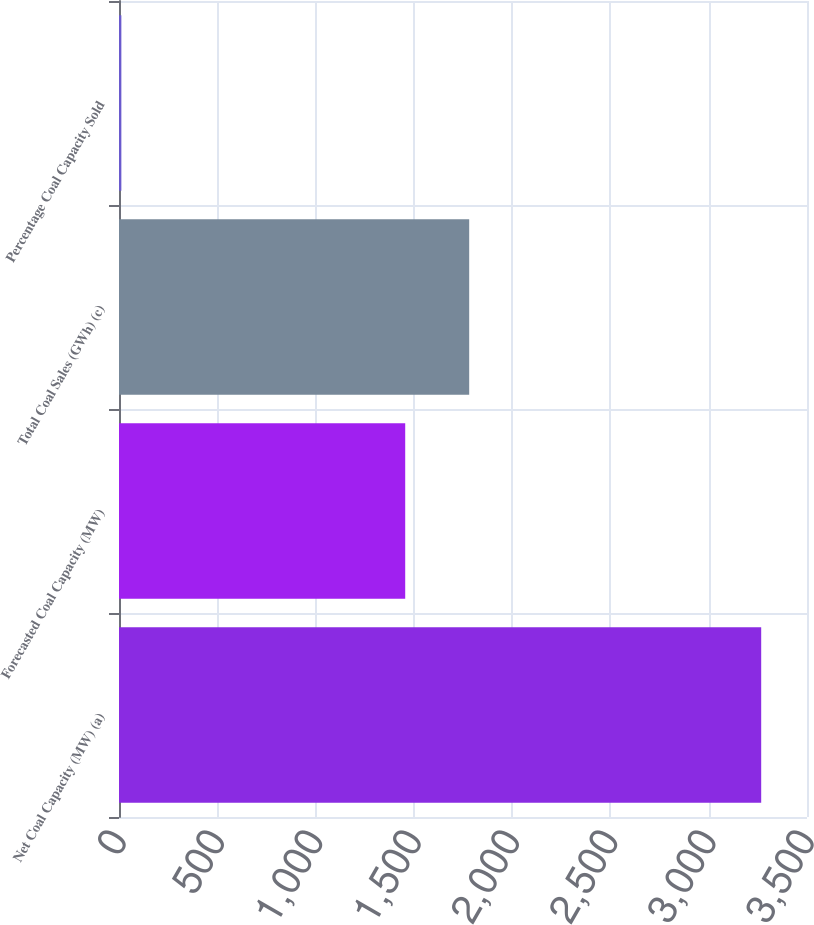<chart> <loc_0><loc_0><loc_500><loc_500><bar_chart><fcel>Net Coal Capacity (MW) (a)<fcel>Forecasted Coal Capacity (MW)<fcel>Total Coal Sales (GWh) (c)<fcel>Percentage Coal Capacity Sold<nl><fcel>3267<fcel>1456<fcel>1781.5<fcel>12<nl></chart> 